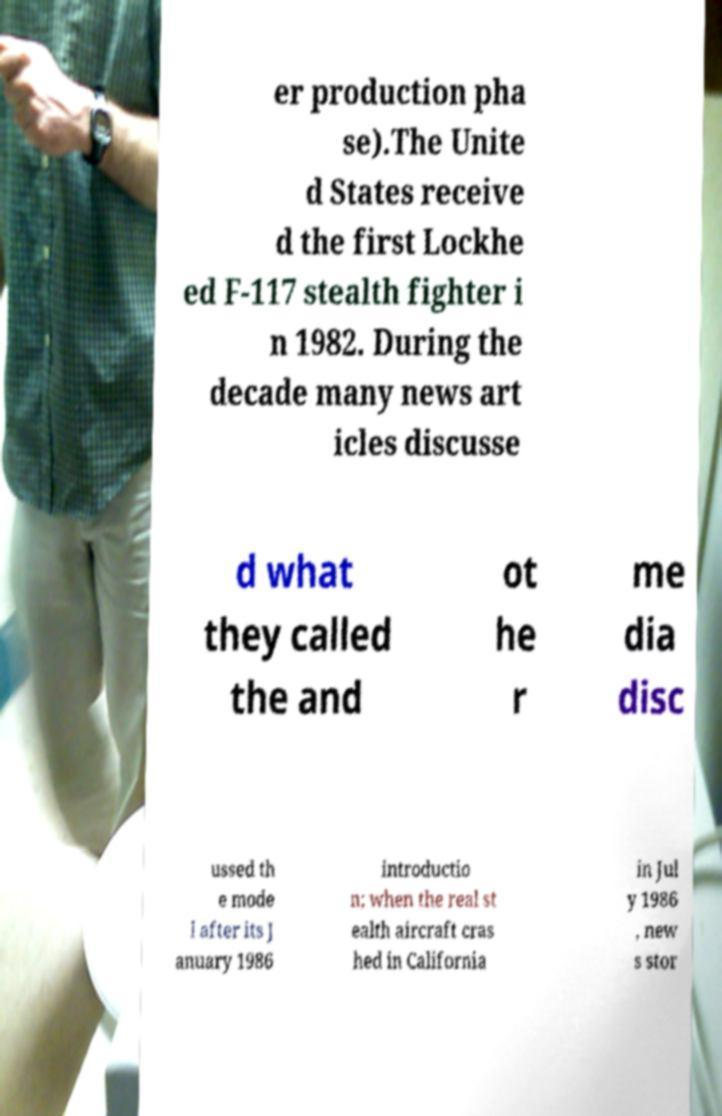What messages or text are displayed in this image? I need them in a readable, typed format. er production pha se).The Unite d States receive d the first Lockhe ed F-117 stealth fighter i n 1982. During the decade many news art icles discusse d what they called the and ot he r me dia disc ussed th e mode l after its J anuary 1986 introductio n; when the real st ealth aircraft cras hed in California in Jul y 1986 , new s stor 